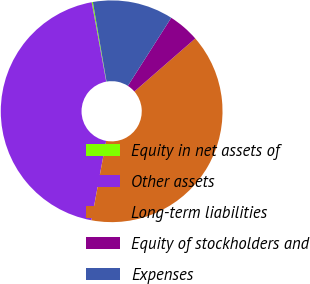<chart> <loc_0><loc_0><loc_500><loc_500><pie_chart><fcel>Equity in net assets of<fcel>Other assets<fcel>Long-term liabilities<fcel>Equity of stockholders and<fcel>Expenses<nl><fcel>0.17%<fcel>44.2%<fcel>39.32%<fcel>4.57%<fcel>11.74%<nl></chart> 